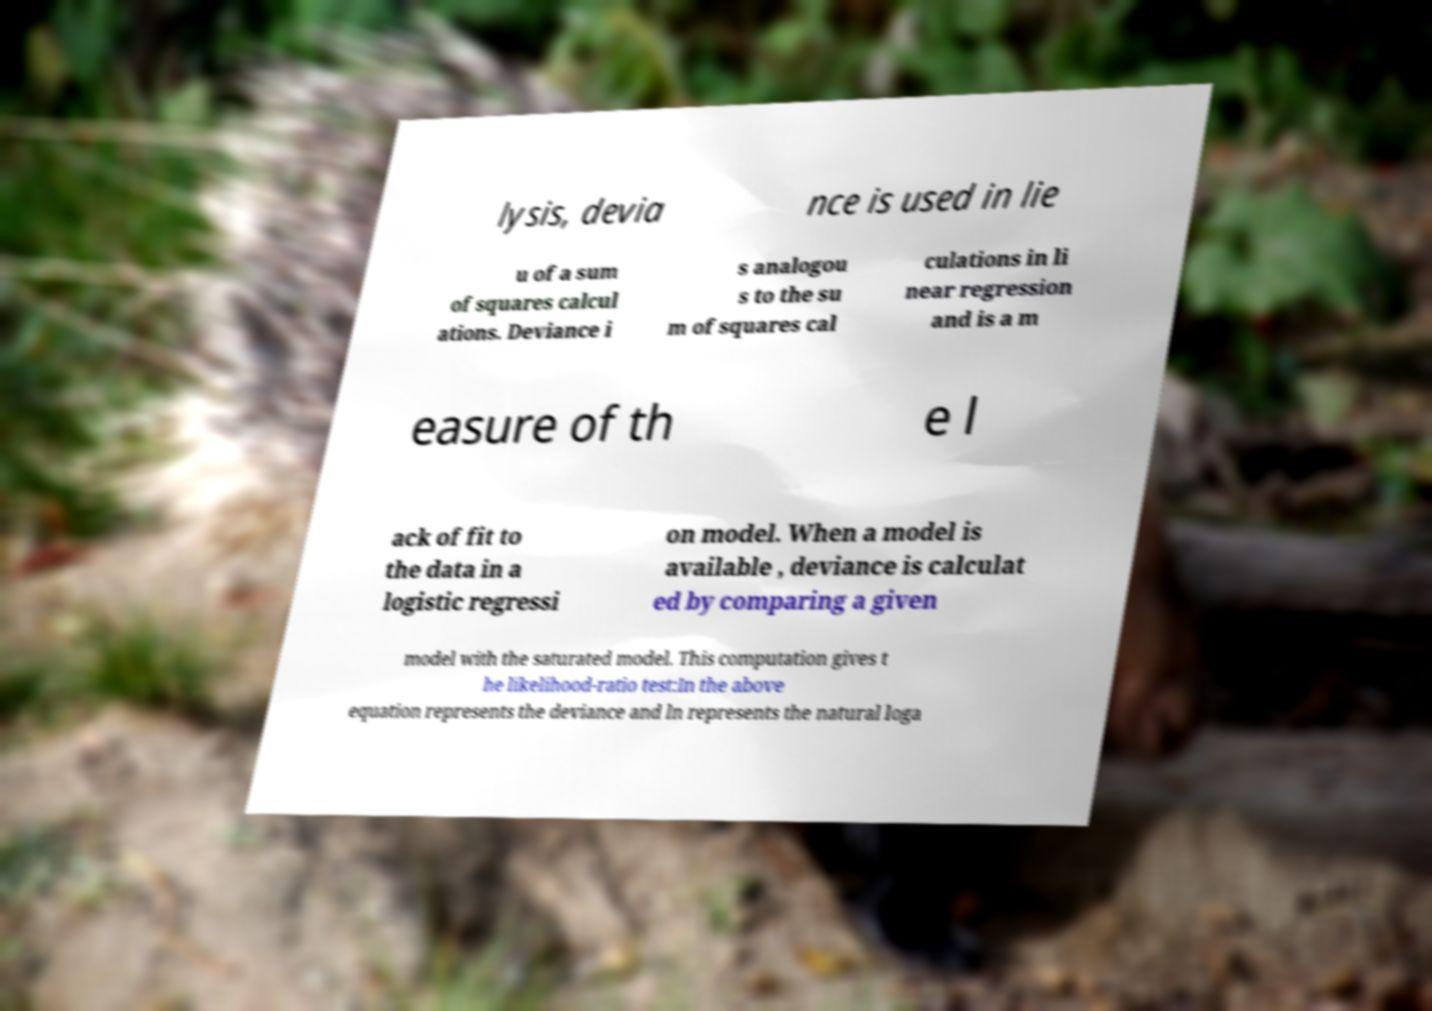I need the written content from this picture converted into text. Can you do that? lysis, devia nce is used in lie u of a sum of squares calcul ations. Deviance i s analogou s to the su m of squares cal culations in li near regression and is a m easure of th e l ack of fit to the data in a logistic regressi on model. When a model is available , deviance is calculat ed by comparing a given model with the saturated model. This computation gives t he likelihood-ratio test:In the above equation represents the deviance and ln represents the natural loga 